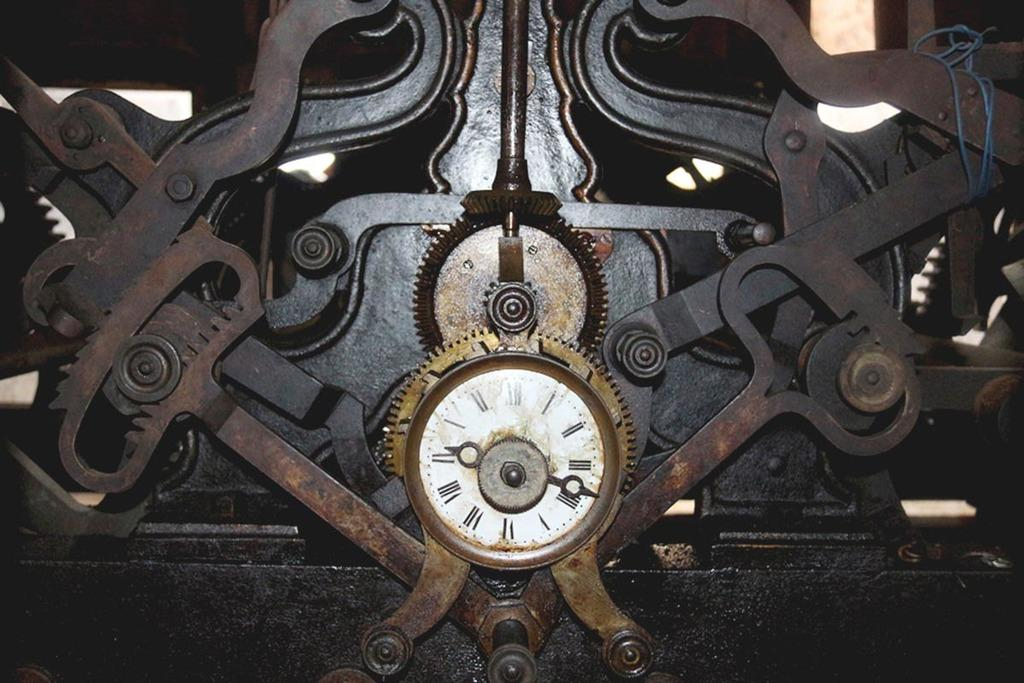What object in the image is used for measuring time? There is a clock in the image that is used for measuring time. What long, thin object can be seen in the image? There is a rod in the image. What type of wire is present in the image? There is a cable in the image. What material is the metal object in the image made of? The metal object in the image is made of metal. What type of paste is being used to hold the clock in place in the image? There is no paste present in the image, and the clock is not being held in place by any adhesive. 